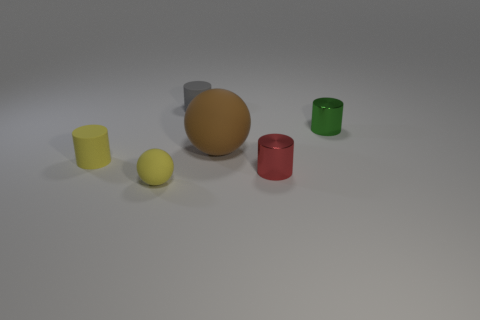Subtract 2 cylinders. How many cylinders are left? 2 Add 2 metal things. How many objects exist? 8 Subtract all cyan balls. Subtract all cyan cubes. How many balls are left? 2 Subtract all cylinders. How many objects are left? 2 Subtract all tiny matte balls. Subtract all small yellow rubber cylinders. How many objects are left? 4 Add 1 small green things. How many small green things are left? 2 Add 3 large things. How many large things exist? 4 Subtract 0 blue cylinders. How many objects are left? 6 